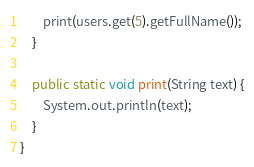Convert code to text. <code><loc_0><loc_0><loc_500><loc_500><_Java_>        print(users.get(5).getFullName());
    }

    public static void print(String text) {
        System.out.println(text);
    }
}</code> 